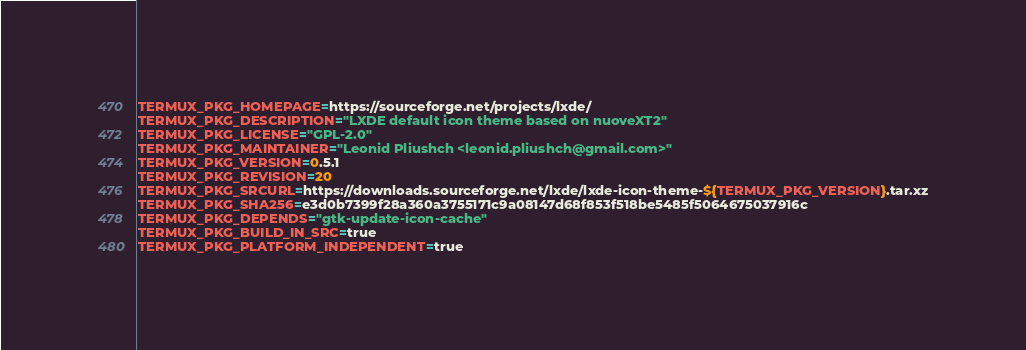Convert code to text. <code><loc_0><loc_0><loc_500><loc_500><_Bash_>TERMUX_PKG_HOMEPAGE=https://sourceforge.net/projects/lxde/
TERMUX_PKG_DESCRIPTION="LXDE default icon theme based on nuoveXT2"
TERMUX_PKG_LICENSE="GPL-2.0"
TERMUX_PKG_MAINTAINER="Leonid Pliushch <leonid.pliushch@gmail.com>"
TERMUX_PKG_VERSION=0.5.1
TERMUX_PKG_REVISION=20
TERMUX_PKG_SRCURL=https://downloads.sourceforge.net/lxde/lxde-icon-theme-${TERMUX_PKG_VERSION}.tar.xz
TERMUX_PKG_SHA256=e3d0b7399f28a360a3755171c9a08147d68f853f518be5485f5064675037916c
TERMUX_PKG_DEPENDS="gtk-update-icon-cache"
TERMUX_PKG_BUILD_IN_SRC=true
TERMUX_PKG_PLATFORM_INDEPENDENT=true
</code> 